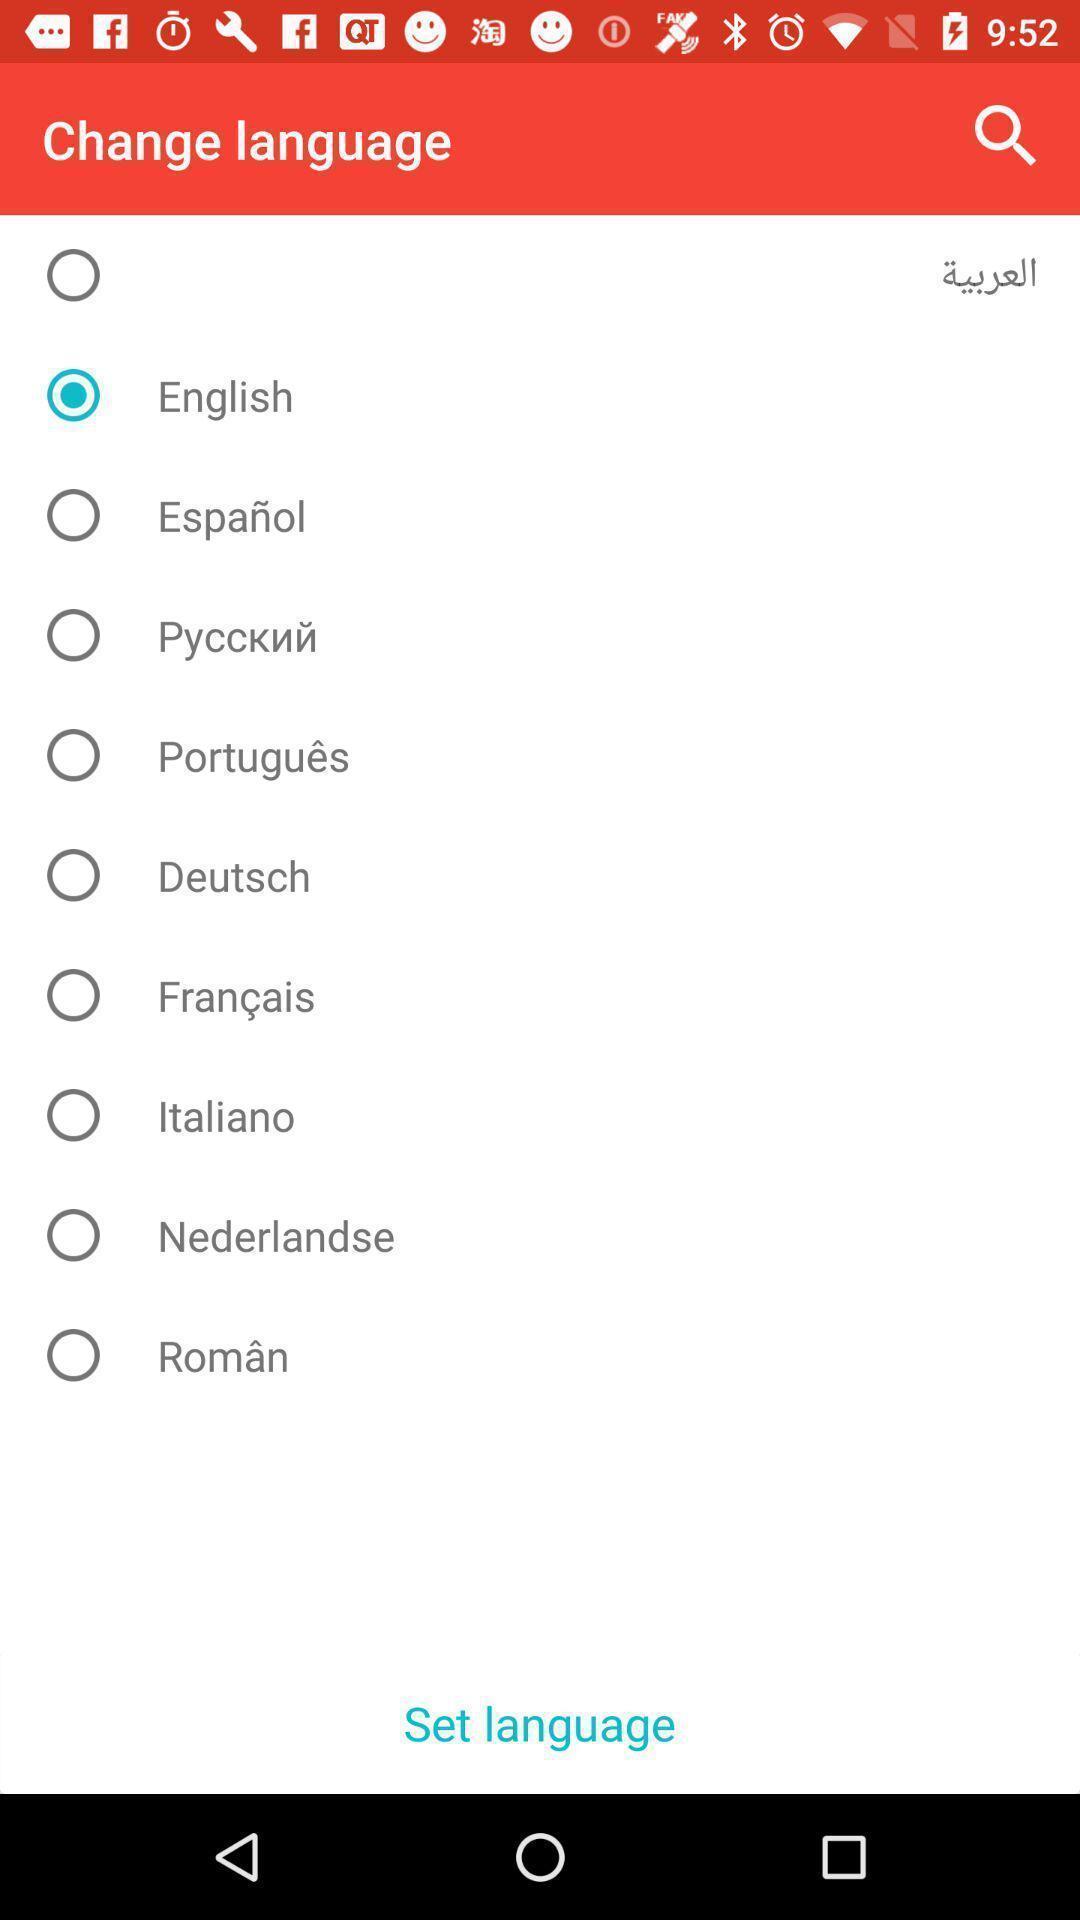Describe the key features of this screenshot. Page showing list of languages. 